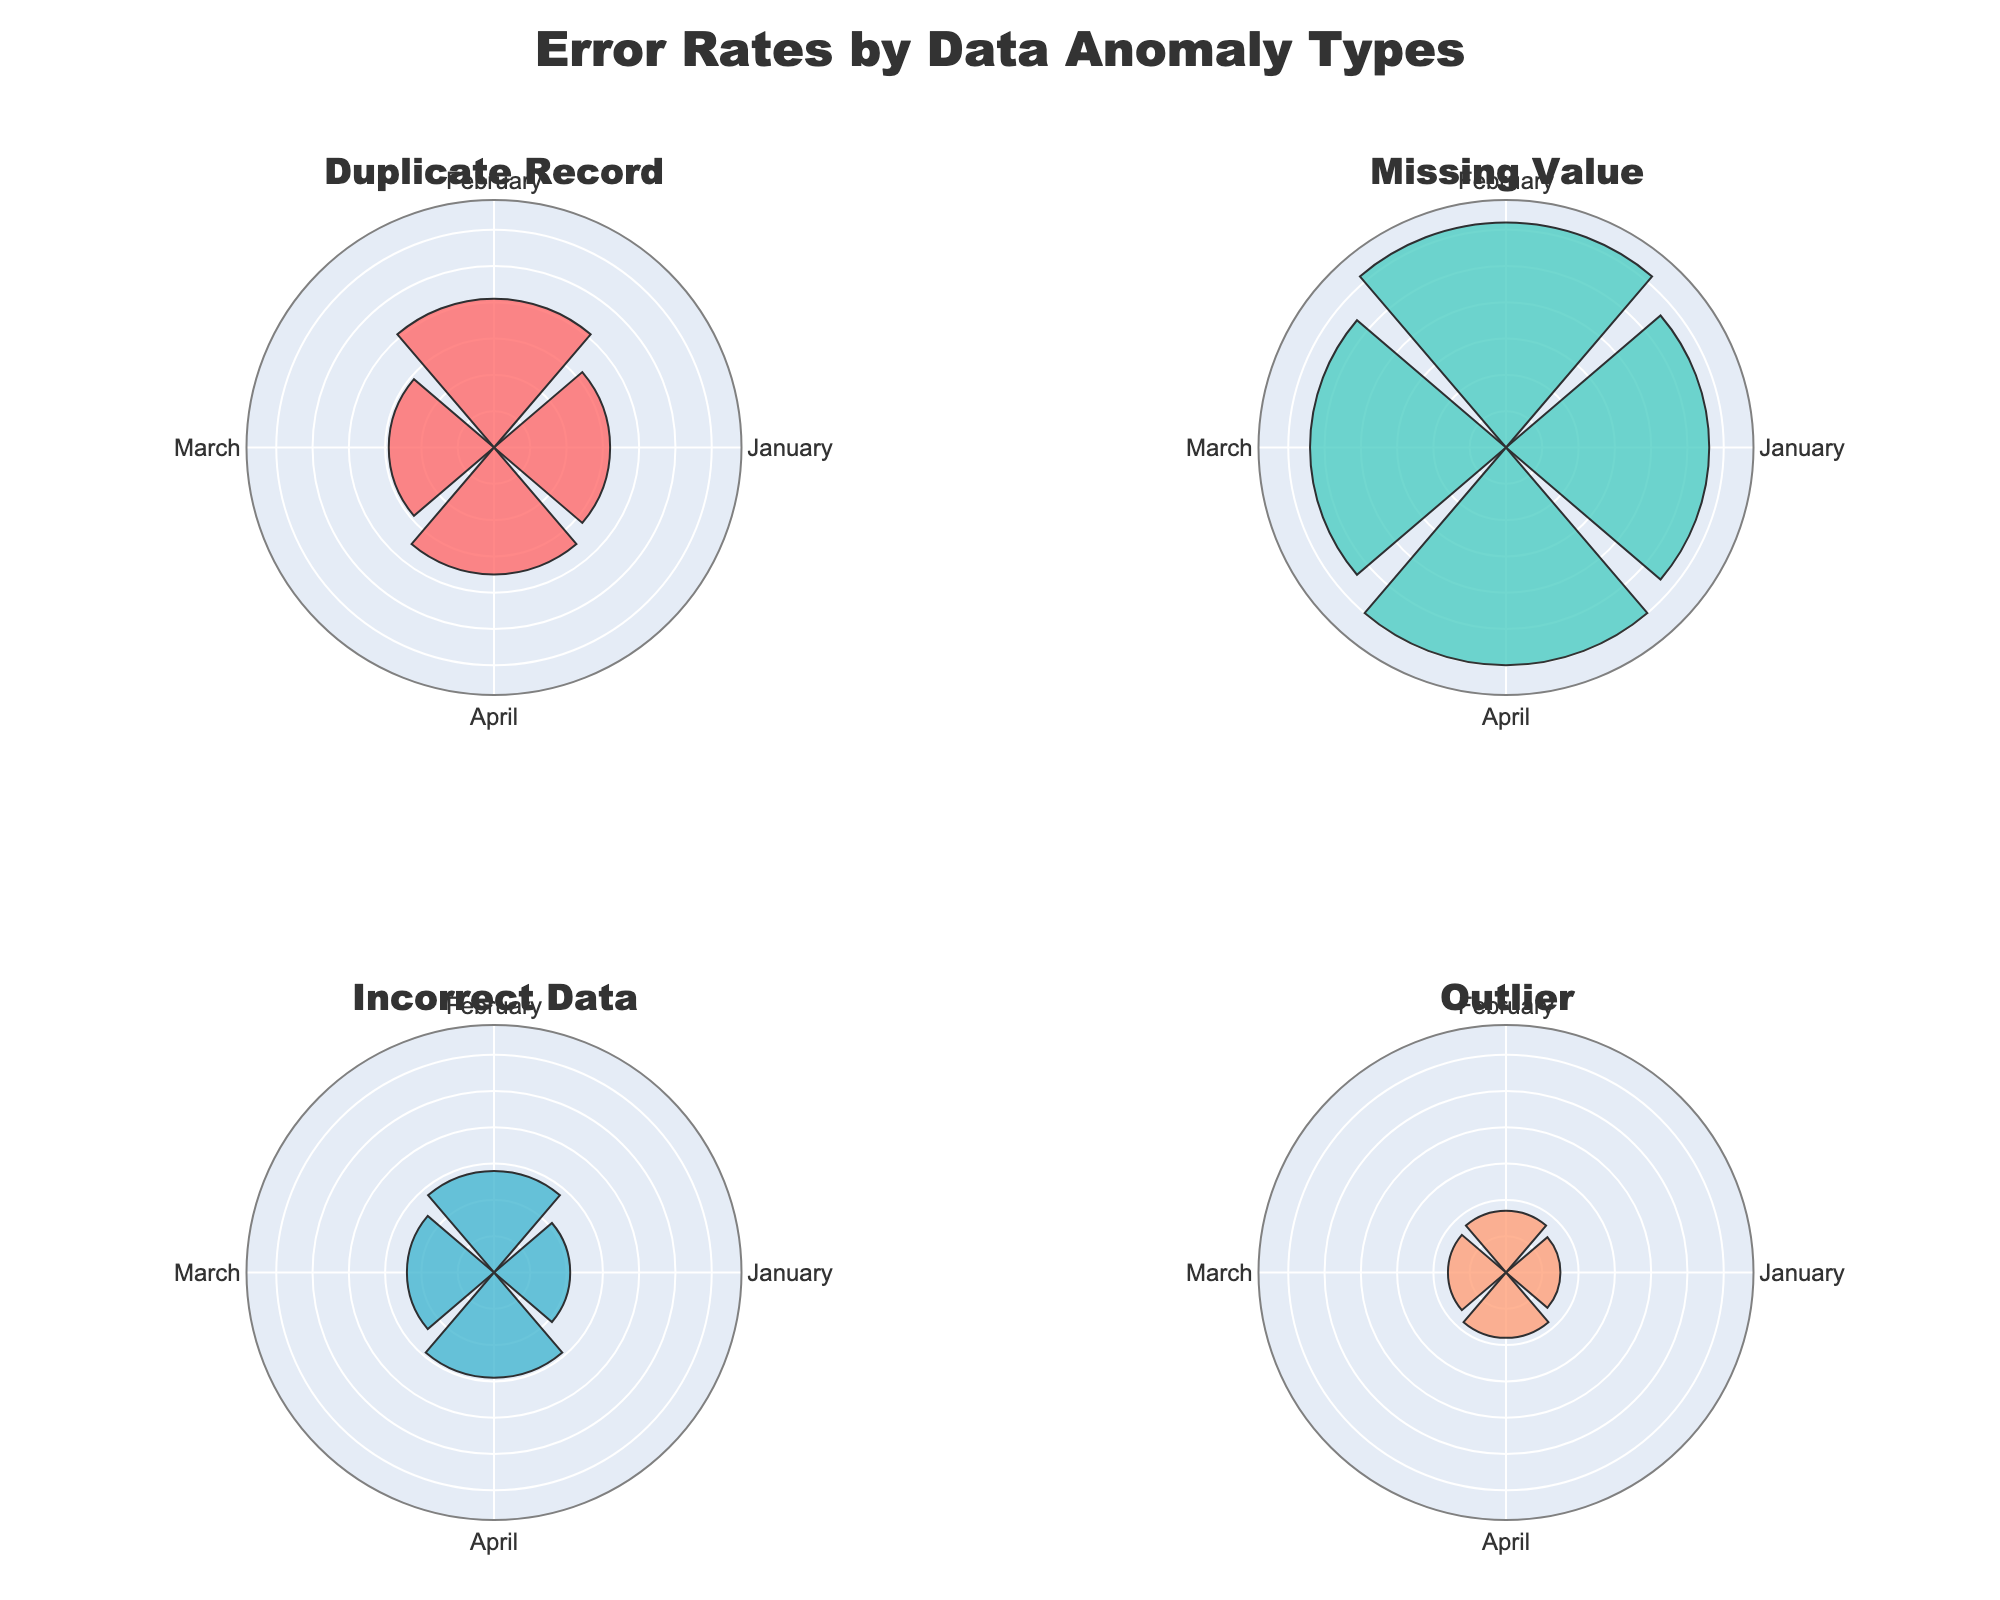What is the title of the figure? The title is usually located at the top center of the plot, and it summarizes the content of the figure. In this case, it reads "Error Rates by Data Anomaly Types".
Answer: Error Rates by Data Anomaly Types Which anomaly type has the highest error rate in January? Look at the polar subplots, find the subplot for January, and compare the error rates for each anomaly type. The "Missing Value" anomaly shows the highest error rate.
Answer: Missing Value What is the average error rate of Duplicate Records over the four months? Sum the error rates for Duplicate Records (3.2 + 4.1 + 2.9 + 3.5) = 13.7, then divide by the number of months, which is 4. The average is 13.7 / 4 = 3.425.
Answer: 3.425 Which month shows the lowest error rate for Incorrect Data anomalies? Find the subplot for Incorrect Data and compare the error rates for each month. January has the lowest error rate of 2.1.
Answer: January How does the error rate for Outliers in February compare to its error rate in March? Look at the error rates for Outliers in February and March. In February, it is 1.7, and in March, it is 1.6. The error rate in February is slightly higher than in March.
Answer: Higher Which anomaly type shows the most consistent error rates across the months? Find the anomaly type where the error rates across the months are closest to each other. Outliers appear to have the most consistent rates, with values close to each other (1.5, 1.7, 1.6, 1.8).
Answer: Outliers What is the total error rate for Missing Value anomalies over four months? Sum the error rates for Missing Value anomalies (5.6 + 6.2 + 5.4 + 6.0) = 23.2.
Answer: 23.2 In which month do we observe the highest overall error rate across all anomaly types? Sum the error rates for all anomaly types in each month and compare. January has (3.2 + 5.6 + 2.1 + 1.5) = 12.4, February has (4.1 + 6.2 + 2.8 + 1.7) = 14.8, March has (2.9 + 5.4 + 2.4 + 1.6) = 12.3, and April has (3.5 + 6.0 + 2.9 + 1.8) = 14.2. February has the highest total error rate.
Answer: February 